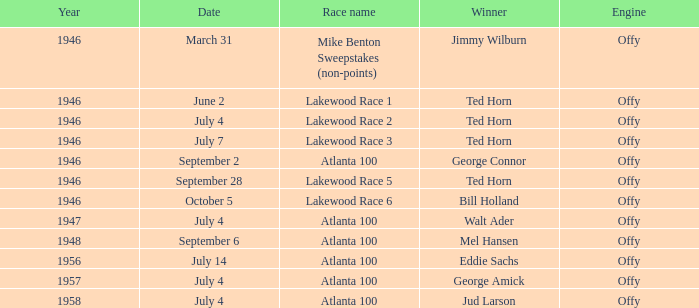Jud Larson who which race after 1956? Atlanta 100. 